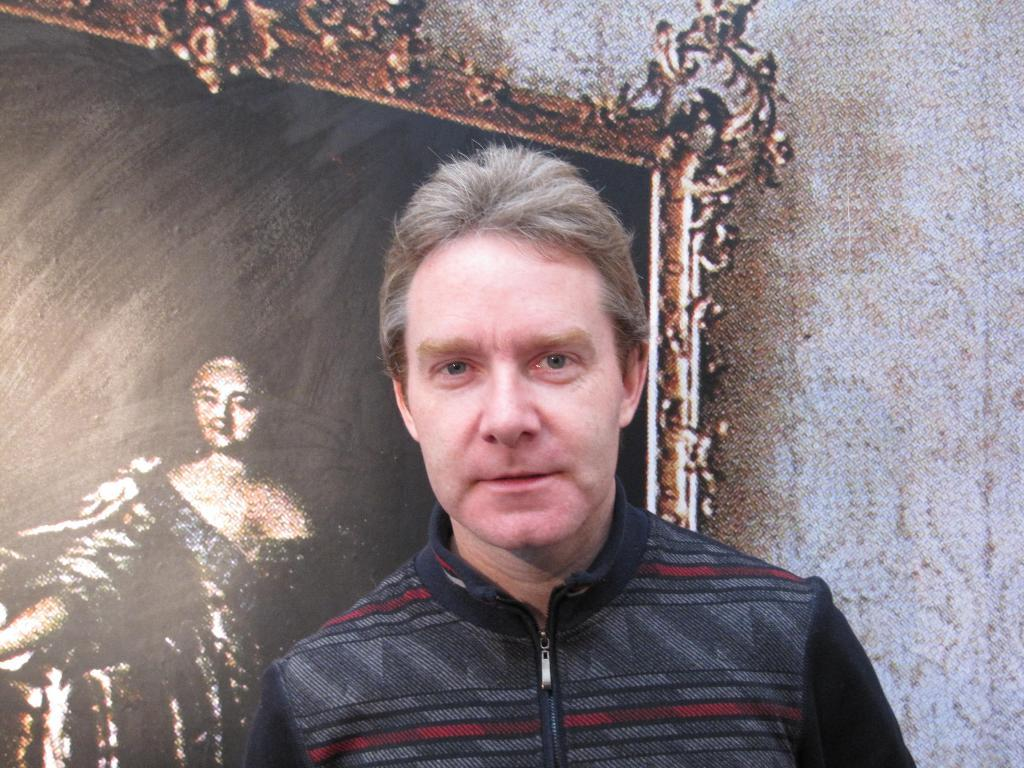What is present in the image? There is a person in the image. Can you describe any additional elements in the background? There is a wall poster of a frame in the background of the image. What type of rose can be smelled in the image? There is no rose present in the image, so it cannot be smelled. 